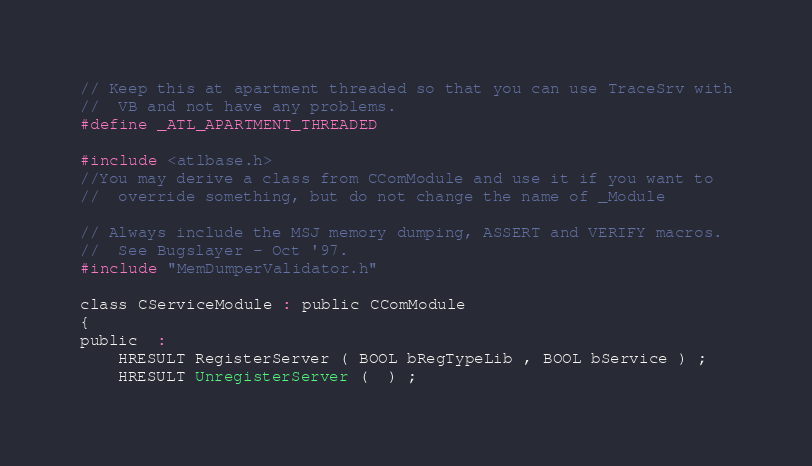Convert code to text. <code><loc_0><loc_0><loc_500><loc_500><_C_>
// Keep this at apartment threaded so that you can use TraceSrv with
//  VB and not have any problems.
#define _ATL_APARTMENT_THREADED

#include <atlbase.h>
//You may derive a class from CComModule and use it if you want to
//  override something, but do not change the name of _Module

// Always include the MSJ memory dumping, ASSERT and VERIFY macros.
//  See Bugslayer - Oct '97.
#include "MemDumperValidator.h"

class CServiceModule : public CComModule
{
public  :
    HRESULT RegisterServer ( BOOL bRegTypeLib , BOOL bService ) ;
    HRESULT UnregisterServer (  ) ;</code> 